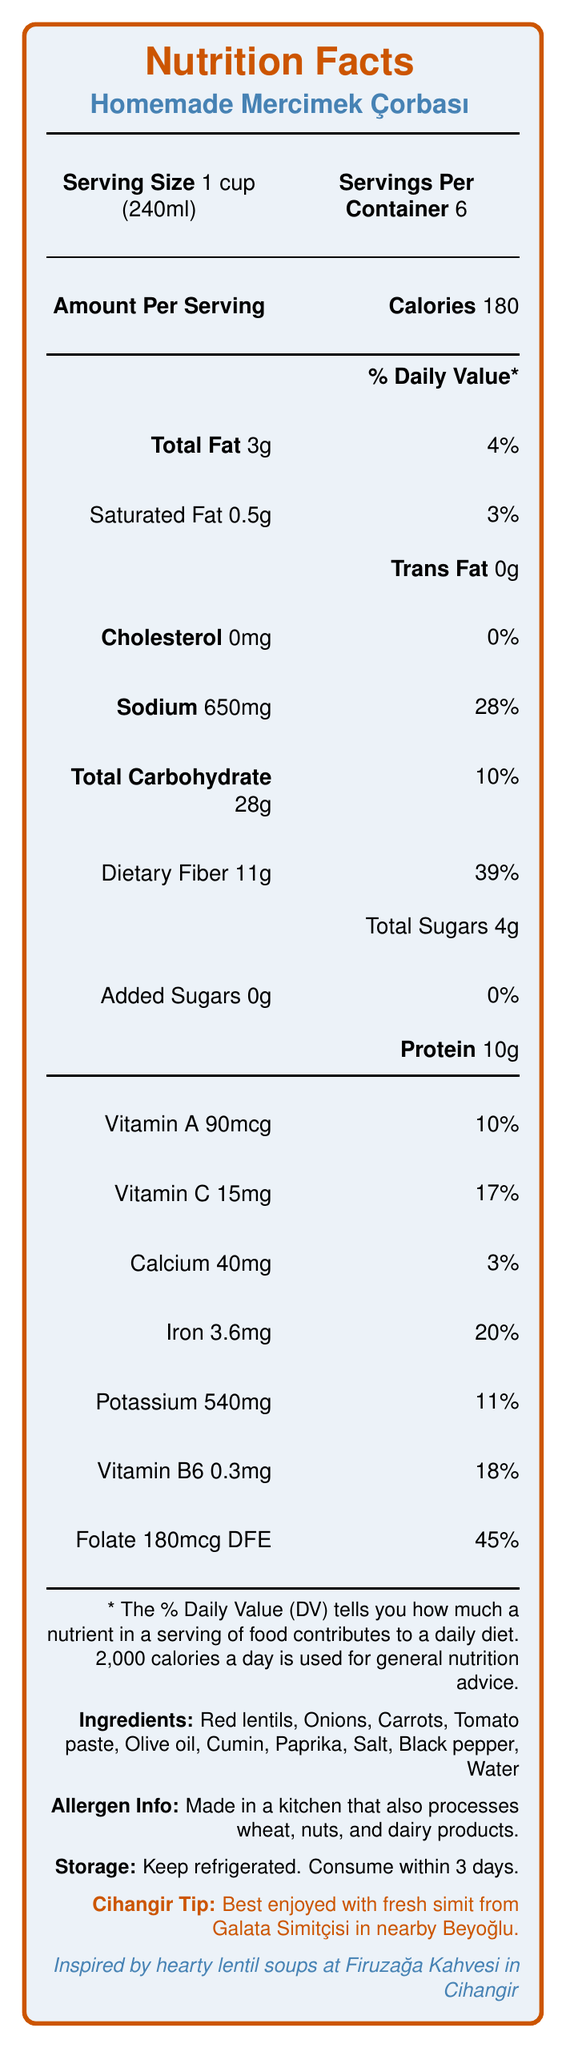what is the serving size? The document mentions that the serving size for Homemade Mercimek Çorbası is 1 cup (240ml).
Answer: 1 cup (240ml) how many servings are there per container? The document specifies that there are 6 servings per container.
Answer: 6 how much dietary fiber is in one serving? The document lists the dietary fiber content for one serving as 11g.
Answer: 11g what is the percent daily value of iron in one serving? The nutritional facts show that iron provides 20% of the daily value per serving.
Answer: 20% is there any trans fat in the soup? The document notes that there is 0g of trans fat in the soup.
Answer: No how many calories are in one serving? The document states that there are 180 calories per serving.
Answer: 180 is the vitamin C content high compared to other nutrients? The vitamin C content is 15mg, which is 17% of the daily value, a relatively high percentage compared to some other nutrients listed.
Answer: Yes, it provides 17% of the daily value which of these nutrients has the highest percent daily value in one serving? A. Vitamin A B. Folate C. Calcium D. Iron E. Vitamin B6 Folate has the highest percent daily value at 45% per serving.
Answer: B. Folate what is the preparation method mentioned in the document? The document states that the soup is simmered and blended.
Answer: Simmered and blended where can you grab a fresh simit to enjoy with this soup? According to the document, the soup is best enjoyed with a slice of fresh simit from Galata Simitçisi in nearby Beyoğlu.
Answer: Galata Simitçisi in Beyoğlu does the soup contain fortified sugars? The document mentions that the soup contains 0g of added sugars.
Answer: No which vitamins listed are provided in significant amounts? (Select all that apply) 1. Vitamin A 2. Vitamin C 3. Calcium 4. Vitamin B6 5. Folate Vitamin C (17%), Vitamin B6 (18%), and Folate (45%) are provided in significant amounts.
Answer: 2, 4, 5 is there any sodium content in the soup? The document indicates that sodium content is 650mg, which is 28% of the daily value per serving.
Answer: Yes summarize this document. The document covers detailed nutritional contents, convenience tips, and a local recommendation for enjoying the soup.
Answer: The document provides the nutrition facts for Homemade Mercimek Çorbası, indicating that it is a good source of dietary fiber, folate, iron, and plant-based protein, while being low in saturated fat. The serving size is 1 cup with 6 servings per container. Additional info includes a suggestion to enjoy it with simit from Galata Simitçisi, and a connection to Firuzağa Kahvesi in Cihangir. how long should you keep the soup refrigerated? The document advises consuming the soup within 3 days if refrigerated.
Answer: Consume within 3 days what is the exact amount of vitamin A per serving? The document specifies that the vitamin A content per serving is 90mcg.
Answer: 90mcg what is the percent daily value for calcium in one serving? The percent daily value for calcium per serving is listed as 3%.
Answer: 3% how many grams of protein does one cup of Mercimek Çorbası provide? The document states that one serving of the soup contains 10g of protein.
Answer: 10g from which local establishment is the inspiration for this soup drawn? The document mentions that this soup is inspired by the hearty lentil soups served at Firuzağa Kahvesi in Cihangir.
Answer: Firuzağa Kahvesi in Cihangir what is the distinction of Mercimek Çorbası regarding saturate fat content? The document highlights that the soup is low in saturated fat.
Answer: Low in saturated fat what is the cooking style described for the soup? The document mentions that the preparation method for the soup includes simmering and blending.
Answer: Simmered and blended what ingredient is not listed in the nutrition facts label, yet might pose an allergen risk? The document specifies allergen info concerning the kitchen, but it does not provide details on ingredients causing potential allergy risks.
Answer: Not enough information 